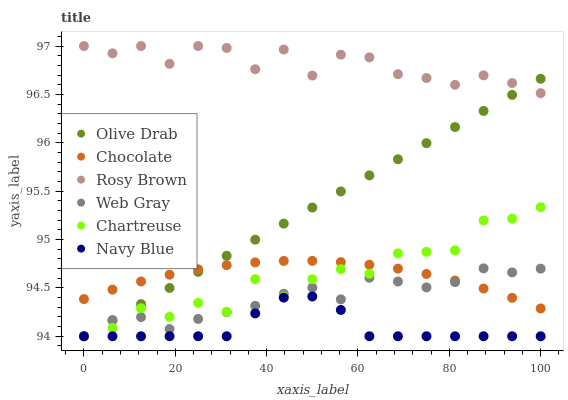Does Navy Blue have the minimum area under the curve?
Answer yes or no. Yes. Does Rosy Brown have the maximum area under the curve?
Answer yes or no. Yes. Does Rosy Brown have the minimum area under the curve?
Answer yes or no. No. Does Navy Blue have the maximum area under the curve?
Answer yes or no. No. Is Olive Drab the smoothest?
Answer yes or no. Yes. Is Chartreuse the roughest?
Answer yes or no. Yes. Is Navy Blue the smoothest?
Answer yes or no. No. Is Navy Blue the roughest?
Answer yes or no. No. Does Web Gray have the lowest value?
Answer yes or no. Yes. Does Rosy Brown have the lowest value?
Answer yes or no. No. Does Rosy Brown have the highest value?
Answer yes or no. Yes. Does Navy Blue have the highest value?
Answer yes or no. No. Is Navy Blue less than Rosy Brown?
Answer yes or no. Yes. Is Chocolate greater than Navy Blue?
Answer yes or no. Yes. Does Chartreuse intersect Chocolate?
Answer yes or no. Yes. Is Chartreuse less than Chocolate?
Answer yes or no. No. Is Chartreuse greater than Chocolate?
Answer yes or no. No. Does Navy Blue intersect Rosy Brown?
Answer yes or no. No. 